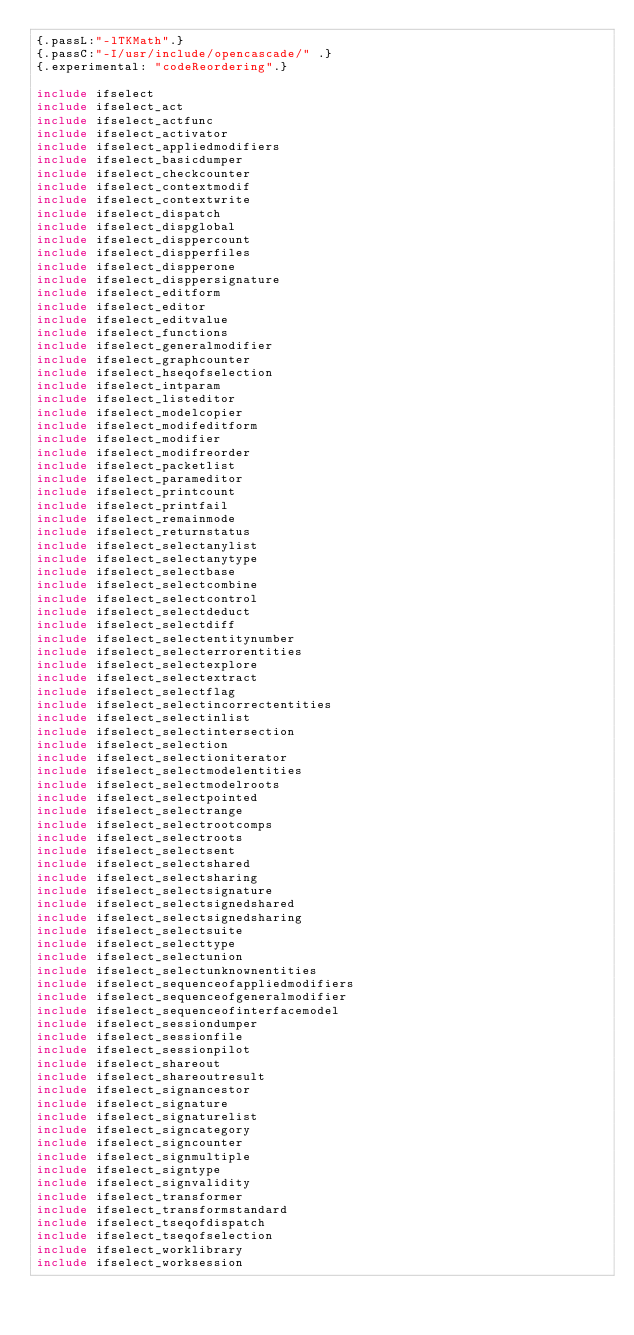<code> <loc_0><loc_0><loc_500><loc_500><_Nim_>{.passL:"-lTKMath".}
{.passC:"-I/usr/include/opencascade/" .}
{.experimental: "codeReordering".}

include ifselect
include ifselect_act
include ifselect_actfunc
include ifselect_activator
include ifselect_appliedmodifiers
include ifselect_basicdumper
include ifselect_checkcounter
include ifselect_contextmodif
include ifselect_contextwrite
include ifselect_dispatch
include ifselect_dispglobal
include ifselect_disppercount
include ifselect_dispperfiles
include ifselect_dispperone
include ifselect_disppersignature
include ifselect_editform
include ifselect_editor
include ifselect_editvalue
include ifselect_functions
include ifselect_generalmodifier
include ifselect_graphcounter
include ifselect_hseqofselection
include ifselect_intparam
include ifselect_listeditor
include ifselect_modelcopier
include ifselect_modifeditform
include ifselect_modifier
include ifselect_modifreorder
include ifselect_packetlist
include ifselect_parameditor
include ifselect_printcount
include ifselect_printfail
include ifselect_remainmode
include ifselect_returnstatus
include ifselect_selectanylist
include ifselect_selectanytype
include ifselect_selectbase
include ifselect_selectcombine
include ifselect_selectcontrol
include ifselect_selectdeduct
include ifselect_selectdiff
include ifselect_selectentitynumber
include ifselect_selecterrorentities
include ifselect_selectexplore
include ifselect_selectextract
include ifselect_selectflag
include ifselect_selectincorrectentities
include ifselect_selectinlist
include ifselect_selectintersection
include ifselect_selection
include ifselect_selectioniterator
include ifselect_selectmodelentities
include ifselect_selectmodelroots
include ifselect_selectpointed
include ifselect_selectrange
include ifselect_selectrootcomps
include ifselect_selectroots
include ifselect_selectsent
include ifselect_selectshared
include ifselect_selectsharing
include ifselect_selectsignature
include ifselect_selectsignedshared
include ifselect_selectsignedsharing
include ifselect_selectsuite
include ifselect_selecttype
include ifselect_selectunion
include ifselect_selectunknownentities
include ifselect_sequenceofappliedmodifiers
include ifselect_sequenceofgeneralmodifier
include ifselect_sequenceofinterfacemodel
include ifselect_sessiondumper
include ifselect_sessionfile
include ifselect_sessionpilot
include ifselect_shareout
include ifselect_shareoutresult
include ifselect_signancestor
include ifselect_signature
include ifselect_signaturelist
include ifselect_signcategory
include ifselect_signcounter
include ifselect_signmultiple
include ifselect_signtype
include ifselect_signvalidity
include ifselect_transformer
include ifselect_transformstandard
include ifselect_tseqofdispatch
include ifselect_tseqofselection
include ifselect_worklibrary
include ifselect_worksession
</code> 